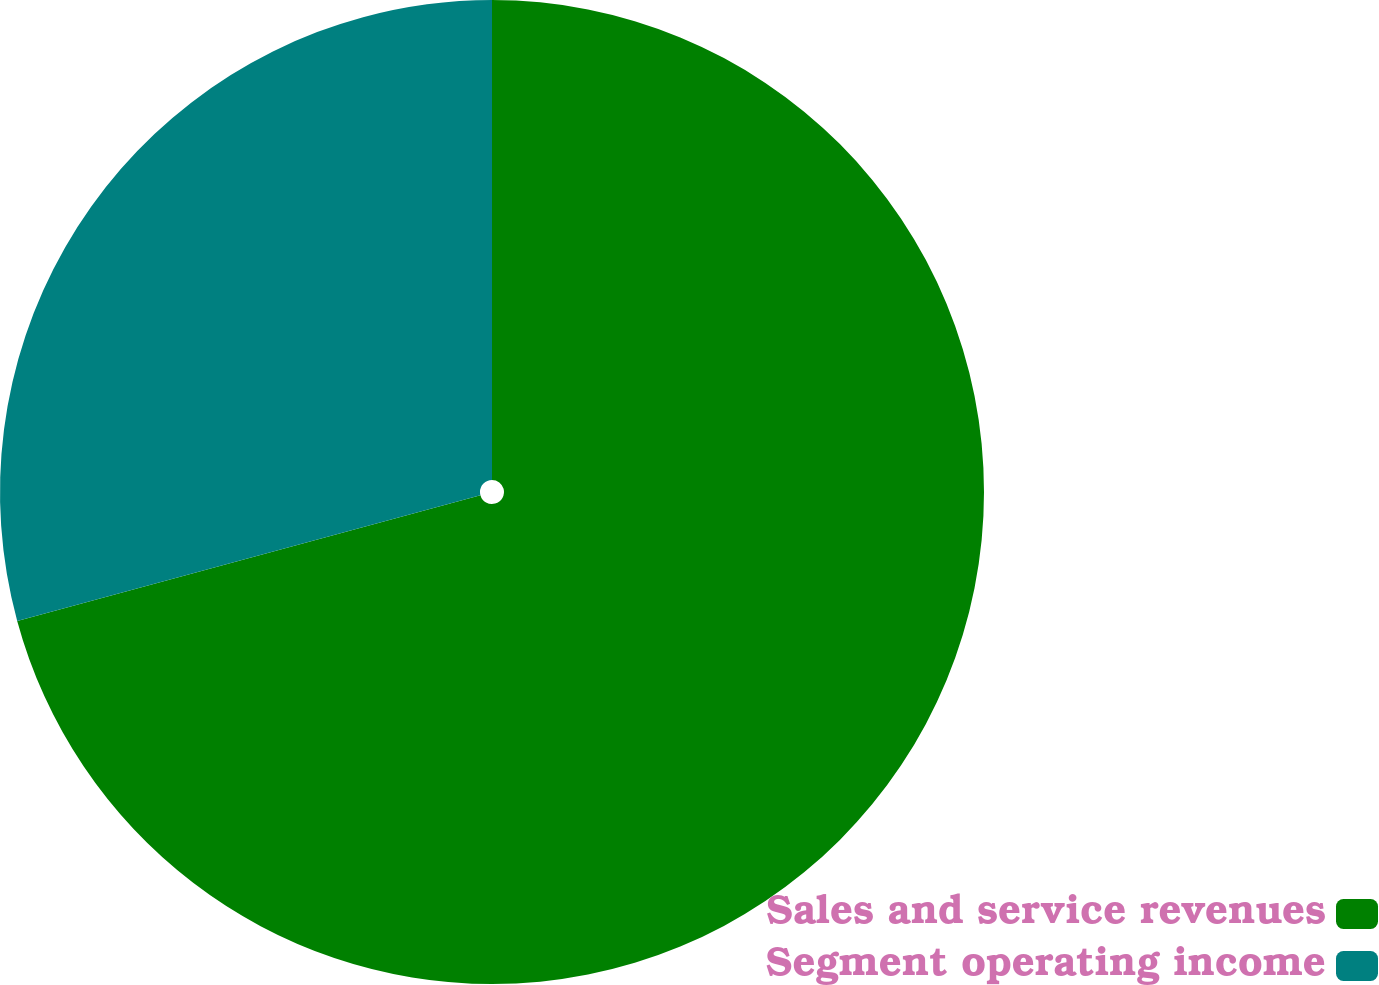<chart> <loc_0><loc_0><loc_500><loc_500><pie_chart><fcel>Sales and service revenues<fcel>Segment operating income<nl><fcel>70.78%<fcel>29.22%<nl></chart> 